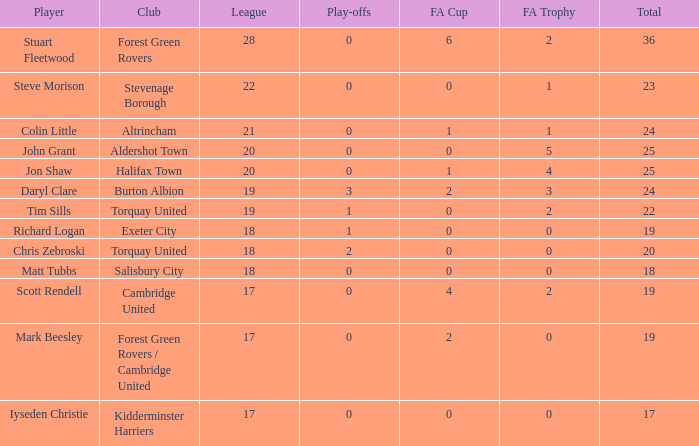What is the mean number of play-offs when the league number was bigger than 18, where the player was John Grant and the total number was bigger than 25? None. 